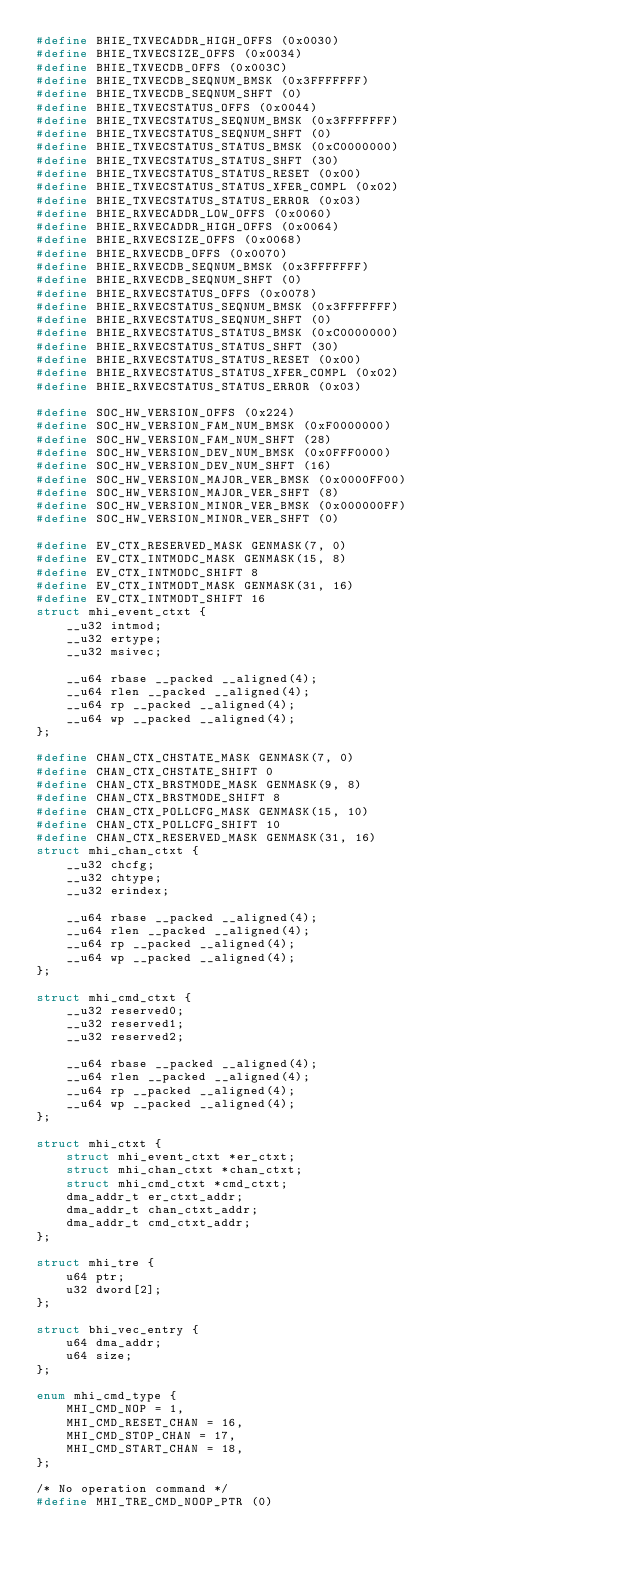<code> <loc_0><loc_0><loc_500><loc_500><_C_>#define BHIE_TXVECADDR_HIGH_OFFS (0x0030)
#define BHIE_TXVECSIZE_OFFS (0x0034)
#define BHIE_TXVECDB_OFFS (0x003C)
#define BHIE_TXVECDB_SEQNUM_BMSK (0x3FFFFFFF)
#define BHIE_TXVECDB_SEQNUM_SHFT (0)
#define BHIE_TXVECSTATUS_OFFS (0x0044)
#define BHIE_TXVECSTATUS_SEQNUM_BMSK (0x3FFFFFFF)
#define BHIE_TXVECSTATUS_SEQNUM_SHFT (0)
#define BHIE_TXVECSTATUS_STATUS_BMSK (0xC0000000)
#define BHIE_TXVECSTATUS_STATUS_SHFT (30)
#define BHIE_TXVECSTATUS_STATUS_RESET (0x00)
#define BHIE_TXVECSTATUS_STATUS_XFER_COMPL (0x02)
#define BHIE_TXVECSTATUS_STATUS_ERROR (0x03)
#define BHIE_RXVECADDR_LOW_OFFS (0x0060)
#define BHIE_RXVECADDR_HIGH_OFFS (0x0064)
#define BHIE_RXVECSIZE_OFFS (0x0068)
#define BHIE_RXVECDB_OFFS (0x0070)
#define BHIE_RXVECDB_SEQNUM_BMSK (0x3FFFFFFF)
#define BHIE_RXVECDB_SEQNUM_SHFT (0)
#define BHIE_RXVECSTATUS_OFFS (0x0078)
#define BHIE_RXVECSTATUS_SEQNUM_BMSK (0x3FFFFFFF)
#define BHIE_RXVECSTATUS_SEQNUM_SHFT (0)
#define BHIE_RXVECSTATUS_STATUS_BMSK (0xC0000000)
#define BHIE_RXVECSTATUS_STATUS_SHFT (30)
#define BHIE_RXVECSTATUS_STATUS_RESET (0x00)
#define BHIE_RXVECSTATUS_STATUS_XFER_COMPL (0x02)
#define BHIE_RXVECSTATUS_STATUS_ERROR (0x03)

#define SOC_HW_VERSION_OFFS (0x224)
#define SOC_HW_VERSION_FAM_NUM_BMSK (0xF0000000)
#define SOC_HW_VERSION_FAM_NUM_SHFT (28)
#define SOC_HW_VERSION_DEV_NUM_BMSK (0x0FFF0000)
#define SOC_HW_VERSION_DEV_NUM_SHFT (16)
#define SOC_HW_VERSION_MAJOR_VER_BMSK (0x0000FF00)
#define SOC_HW_VERSION_MAJOR_VER_SHFT (8)
#define SOC_HW_VERSION_MINOR_VER_BMSK (0x000000FF)
#define SOC_HW_VERSION_MINOR_VER_SHFT (0)

#define EV_CTX_RESERVED_MASK GENMASK(7, 0)
#define EV_CTX_INTMODC_MASK GENMASK(15, 8)
#define EV_CTX_INTMODC_SHIFT 8
#define EV_CTX_INTMODT_MASK GENMASK(31, 16)
#define EV_CTX_INTMODT_SHIFT 16
struct mhi_event_ctxt {
	__u32 intmod;
	__u32 ertype;
	__u32 msivec;

	__u64 rbase __packed __aligned(4);
	__u64 rlen __packed __aligned(4);
	__u64 rp __packed __aligned(4);
	__u64 wp __packed __aligned(4);
};

#define CHAN_CTX_CHSTATE_MASK GENMASK(7, 0)
#define CHAN_CTX_CHSTATE_SHIFT 0
#define CHAN_CTX_BRSTMODE_MASK GENMASK(9, 8)
#define CHAN_CTX_BRSTMODE_SHIFT 8
#define CHAN_CTX_POLLCFG_MASK GENMASK(15, 10)
#define CHAN_CTX_POLLCFG_SHIFT 10
#define CHAN_CTX_RESERVED_MASK GENMASK(31, 16)
struct mhi_chan_ctxt {
	__u32 chcfg;
	__u32 chtype;
	__u32 erindex;

	__u64 rbase __packed __aligned(4);
	__u64 rlen __packed __aligned(4);
	__u64 rp __packed __aligned(4);
	__u64 wp __packed __aligned(4);
};

struct mhi_cmd_ctxt {
	__u32 reserved0;
	__u32 reserved1;
	__u32 reserved2;

	__u64 rbase __packed __aligned(4);
	__u64 rlen __packed __aligned(4);
	__u64 rp __packed __aligned(4);
	__u64 wp __packed __aligned(4);
};

struct mhi_ctxt {
	struct mhi_event_ctxt *er_ctxt;
	struct mhi_chan_ctxt *chan_ctxt;
	struct mhi_cmd_ctxt *cmd_ctxt;
	dma_addr_t er_ctxt_addr;
	dma_addr_t chan_ctxt_addr;
	dma_addr_t cmd_ctxt_addr;
};

struct mhi_tre {
	u64 ptr;
	u32 dword[2];
};

struct bhi_vec_entry {
	u64 dma_addr;
	u64 size;
};

enum mhi_cmd_type {
	MHI_CMD_NOP = 1,
	MHI_CMD_RESET_CHAN = 16,
	MHI_CMD_STOP_CHAN = 17,
	MHI_CMD_START_CHAN = 18,
};

/* No operation command */
#define MHI_TRE_CMD_NOOP_PTR (0)</code> 